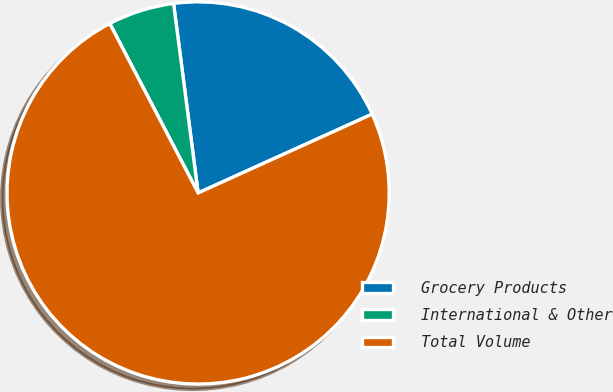Convert chart. <chart><loc_0><loc_0><loc_500><loc_500><pie_chart><fcel>Grocery Products<fcel>International & Other<fcel>Total Volume<nl><fcel>20.28%<fcel>5.6%<fcel>74.12%<nl></chart> 